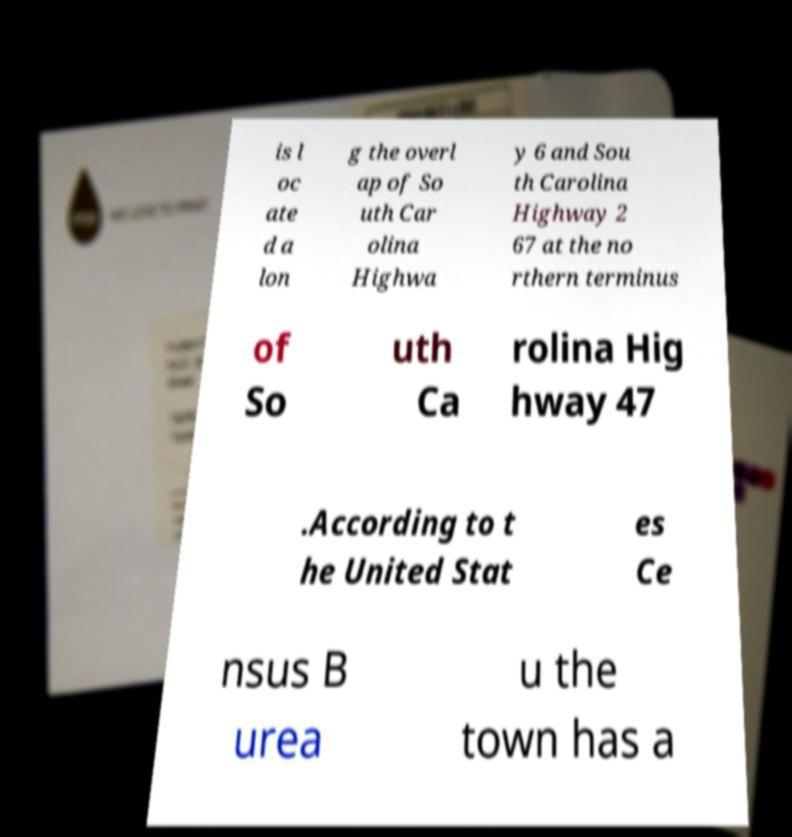There's text embedded in this image that I need extracted. Can you transcribe it verbatim? is l oc ate d a lon g the overl ap of So uth Car olina Highwa y 6 and Sou th Carolina Highway 2 67 at the no rthern terminus of So uth Ca rolina Hig hway 47 .According to t he United Stat es Ce nsus B urea u the town has a 